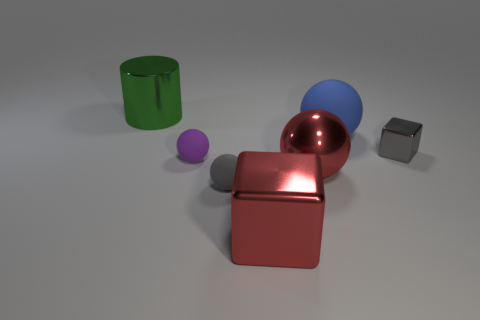What number of things are matte spheres that are in front of the small gray metallic cube or tiny green rubber objects?
Ensure brevity in your answer.  2. Does the metallic sphere have the same color as the big cube?
Offer a terse response. Yes. There is a block that is to the right of the large cube; how big is it?
Provide a succinct answer. Small. Is there a gray cube that has the same size as the red block?
Provide a succinct answer. No. Do the cube on the left side of the blue sphere and the red sphere have the same size?
Give a very brief answer. Yes. What is the size of the gray metallic thing?
Your answer should be compact. Small. There is a metal block right of the cube in front of the metal thing on the right side of the blue matte thing; what color is it?
Provide a succinct answer. Gray. Is the color of the metal cube to the left of the small gray metallic block the same as the big metallic sphere?
Provide a short and direct response. Yes. How many large metallic objects are in front of the small purple ball and behind the blue sphere?
Your answer should be compact. 0. The other red object that is the same shape as the big matte object is what size?
Your answer should be very brief. Large. 